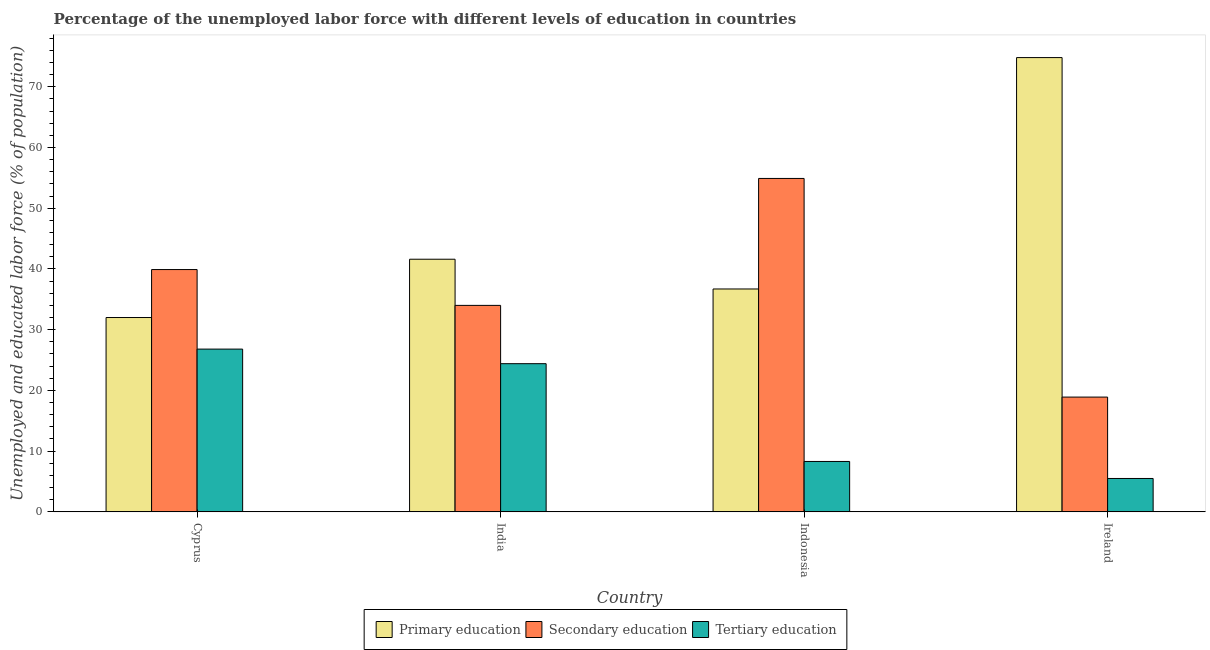How many groups of bars are there?
Your answer should be compact. 4. Are the number of bars per tick equal to the number of legend labels?
Your response must be concise. Yes. How many bars are there on the 3rd tick from the left?
Make the answer very short. 3. How many bars are there on the 1st tick from the right?
Provide a succinct answer. 3. What is the label of the 3rd group of bars from the left?
Provide a succinct answer. Indonesia. In how many cases, is the number of bars for a given country not equal to the number of legend labels?
Keep it short and to the point. 0. What is the percentage of labor force who received primary education in Indonesia?
Your response must be concise. 36.7. Across all countries, what is the maximum percentage of labor force who received tertiary education?
Your response must be concise. 26.8. Across all countries, what is the minimum percentage of labor force who received secondary education?
Provide a succinct answer. 18.9. In which country was the percentage of labor force who received primary education maximum?
Give a very brief answer. Ireland. In which country was the percentage of labor force who received primary education minimum?
Offer a very short reply. Cyprus. What is the total percentage of labor force who received primary education in the graph?
Keep it short and to the point. 185.1. What is the difference between the percentage of labor force who received secondary education in Cyprus and that in India?
Keep it short and to the point. 5.9. What is the difference between the percentage of labor force who received primary education in Cyprus and the percentage of labor force who received secondary education in Ireland?
Give a very brief answer. 13.1. What is the average percentage of labor force who received tertiary education per country?
Provide a short and direct response. 16.25. What is the difference between the percentage of labor force who received tertiary education and percentage of labor force who received secondary education in Indonesia?
Make the answer very short. -46.6. What is the ratio of the percentage of labor force who received secondary education in India to that in Ireland?
Make the answer very short. 1.8. What is the difference between the highest and the second highest percentage of labor force who received tertiary education?
Provide a short and direct response. 2.4. What is the difference between the highest and the lowest percentage of labor force who received primary education?
Ensure brevity in your answer.  42.8. Is the sum of the percentage of labor force who received tertiary education in India and Ireland greater than the maximum percentage of labor force who received secondary education across all countries?
Your response must be concise. No. What does the 2nd bar from the left in India represents?
Your answer should be compact. Secondary education. What does the 1st bar from the right in Ireland represents?
Your answer should be very brief. Tertiary education. Is it the case that in every country, the sum of the percentage of labor force who received primary education and percentage of labor force who received secondary education is greater than the percentage of labor force who received tertiary education?
Your answer should be very brief. Yes. Are all the bars in the graph horizontal?
Provide a short and direct response. No. How many countries are there in the graph?
Provide a short and direct response. 4. Does the graph contain any zero values?
Make the answer very short. No. Where does the legend appear in the graph?
Offer a terse response. Bottom center. How many legend labels are there?
Ensure brevity in your answer.  3. What is the title of the graph?
Keep it short and to the point. Percentage of the unemployed labor force with different levels of education in countries. Does "Self-employed" appear as one of the legend labels in the graph?
Offer a terse response. No. What is the label or title of the Y-axis?
Provide a short and direct response. Unemployed and educated labor force (% of population). What is the Unemployed and educated labor force (% of population) of Secondary education in Cyprus?
Keep it short and to the point. 39.9. What is the Unemployed and educated labor force (% of population) of Tertiary education in Cyprus?
Offer a terse response. 26.8. What is the Unemployed and educated labor force (% of population) of Primary education in India?
Offer a terse response. 41.6. What is the Unemployed and educated labor force (% of population) in Tertiary education in India?
Give a very brief answer. 24.4. What is the Unemployed and educated labor force (% of population) in Primary education in Indonesia?
Provide a succinct answer. 36.7. What is the Unemployed and educated labor force (% of population) of Secondary education in Indonesia?
Provide a short and direct response. 54.9. What is the Unemployed and educated labor force (% of population) in Tertiary education in Indonesia?
Your response must be concise. 8.3. What is the Unemployed and educated labor force (% of population) of Primary education in Ireland?
Provide a succinct answer. 74.8. What is the Unemployed and educated labor force (% of population) in Secondary education in Ireland?
Provide a short and direct response. 18.9. Across all countries, what is the maximum Unemployed and educated labor force (% of population) of Primary education?
Provide a succinct answer. 74.8. Across all countries, what is the maximum Unemployed and educated labor force (% of population) in Secondary education?
Your answer should be compact. 54.9. Across all countries, what is the maximum Unemployed and educated labor force (% of population) in Tertiary education?
Your answer should be very brief. 26.8. Across all countries, what is the minimum Unemployed and educated labor force (% of population) in Secondary education?
Your answer should be very brief. 18.9. Across all countries, what is the minimum Unemployed and educated labor force (% of population) in Tertiary education?
Offer a terse response. 5.5. What is the total Unemployed and educated labor force (% of population) in Primary education in the graph?
Your answer should be very brief. 185.1. What is the total Unemployed and educated labor force (% of population) in Secondary education in the graph?
Offer a terse response. 147.7. What is the total Unemployed and educated labor force (% of population) in Tertiary education in the graph?
Your answer should be compact. 65. What is the difference between the Unemployed and educated labor force (% of population) in Secondary education in Cyprus and that in India?
Your response must be concise. 5.9. What is the difference between the Unemployed and educated labor force (% of population) of Primary education in Cyprus and that in Ireland?
Ensure brevity in your answer.  -42.8. What is the difference between the Unemployed and educated labor force (% of population) in Secondary education in Cyprus and that in Ireland?
Keep it short and to the point. 21. What is the difference between the Unemployed and educated labor force (% of population) in Tertiary education in Cyprus and that in Ireland?
Offer a very short reply. 21.3. What is the difference between the Unemployed and educated labor force (% of population) of Primary education in India and that in Indonesia?
Make the answer very short. 4.9. What is the difference between the Unemployed and educated labor force (% of population) of Secondary education in India and that in Indonesia?
Give a very brief answer. -20.9. What is the difference between the Unemployed and educated labor force (% of population) in Tertiary education in India and that in Indonesia?
Your response must be concise. 16.1. What is the difference between the Unemployed and educated labor force (% of population) of Primary education in India and that in Ireland?
Provide a succinct answer. -33.2. What is the difference between the Unemployed and educated labor force (% of population) in Tertiary education in India and that in Ireland?
Give a very brief answer. 18.9. What is the difference between the Unemployed and educated labor force (% of population) of Primary education in Indonesia and that in Ireland?
Your answer should be very brief. -38.1. What is the difference between the Unemployed and educated labor force (% of population) of Secondary education in Indonesia and that in Ireland?
Your answer should be very brief. 36. What is the difference between the Unemployed and educated labor force (% of population) of Tertiary education in Indonesia and that in Ireland?
Make the answer very short. 2.8. What is the difference between the Unemployed and educated labor force (% of population) in Secondary education in Cyprus and the Unemployed and educated labor force (% of population) in Tertiary education in India?
Your answer should be compact. 15.5. What is the difference between the Unemployed and educated labor force (% of population) of Primary education in Cyprus and the Unemployed and educated labor force (% of population) of Secondary education in Indonesia?
Your answer should be very brief. -22.9. What is the difference between the Unemployed and educated labor force (% of population) of Primary education in Cyprus and the Unemployed and educated labor force (% of population) of Tertiary education in Indonesia?
Make the answer very short. 23.7. What is the difference between the Unemployed and educated labor force (% of population) of Secondary education in Cyprus and the Unemployed and educated labor force (% of population) of Tertiary education in Indonesia?
Provide a short and direct response. 31.6. What is the difference between the Unemployed and educated labor force (% of population) in Primary education in Cyprus and the Unemployed and educated labor force (% of population) in Secondary education in Ireland?
Your response must be concise. 13.1. What is the difference between the Unemployed and educated labor force (% of population) in Secondary education in Cyprus and the Unemployed and educated labor force (% of population) in Tertiary education in Ireland?
Provide a short and direct response. 34.4. What is the difference between the Unemployed and educated labor force (% of population) of Primary education in India and the Unemployed and educated labor force (% of population) of Tertiary education in Indonesia?
Provide a short and direct response. 33.3. What is the difference between the Unemployed and educated labor force (% of population) in Secondary education in India and the Unemployed and educated labor force (% of population) in Tertiary education in Indonesia?
Give a very brief answer. 25.7. What is the difference between the Unemployed and educated labor force (% of population) of Primary education in India and the Unemployed and educated labor force (% of population) of Secondary education in Ireland?
Your response must be concise. 22.7. What is the difference between the Unemployed and educated labor force (% of population) in Primary education in India and the Unemployed and educated labor force (% of population) in Tertiary education in Ireland?
Your response must be concise. 36.1. What is the difference between the Unemployed and educated labor force (% of population) in Primary education in Indonesia and the Unemployed and educated labor force (% of population) in Tertiary education in Ireland?
Provide a short and direct response. 31.2. What is the difference between the Unemployed and educated labor force (% of population) in Secondary education in Indonesia and the Unemployed and educated labor force (% of population) in Tertiary education in Ireland?
Your response must be concise. 49.4. What is the average Unemployed and educated labor force (% of population) of Primary education per country?
Offer a very short reply. 46.27. What is the average Unemployed and educated labor force (% of population) of Secondary education per country?
Provide a succinct answer. 36.92. What is the average Unemployed and educated labor force (% of population) in Tertiary education per country?
Offer a terse response. 16.25. What is the difference between the Unemployed and educated labor force (% of population) in Primary education and Unemployed and educated labor force (% of population) in Secondary education in Cyprus?
Provide a short and direct response. -7.9. What is the difference between the Unemployed and educated labor force (% of population) of Secondary education and Unemployed and educated labor force (% of population) of Tertiary education in Cyprus?
Provide a succinct answer. 13.1. What is the difference between the Unemployed and educated labor force (% of population) of Primary education and Unemployed and educated labor force (% of population) of Secondary education in India?
Keep it short and to the point. 7.6. What is the difference between the Unemployed and educated labor force (% of population) in Secondary education and Unemployed and educated labor force (% of population) in Tertiary education in India?
Provide a succinct answer. 9.6. What is the difference between the Unemployed and educated labor force (% of population) of Primary education and Unemployed and educated labor force (% of population) of Secondary education in Indonesia?
Your response must be concise. -18.2. What is the difference between the Unemployed and educated labor force (% of population) of Primary education and Unemployed and educated labor force (% of population) of Tertiary education in Indonesia?
Keep it short and to the point. 28.4. What is the difference between the Unemployed and educated labor force (% of population) of Secondary education and Unemployed and educated labor force (% of population) of Tertiary education in Indonesia?
Ensure brevity in your answer.  46.6. What is the difference between the Unemployed and educated labor force (% of population) of Primary education and Unemployed and educated labor force (% of population) of Secondary education in Ireland?
Your answer should be very brief. 55.9. What is the difference between the Unemployed and educated labor force (% of population) in Primary education and Unemployed and educated labor force (% of population) in Tertiary education in Ireland?
Give a very brief answer. 69.3. What is the ratio of the Unemployed and educated labor force (% of population) of Primary education in Cyprus to that in India?
Offer a terse response. 0.77. What is the ratio of the Unemployed and educated labor force (% of population) of Secondary education in Cyprus to that in India?
Your answer should be compact. 1.17. What is the ratio of the Unemployed and educated labor force (% of population) of Tertiary education in Cyprus to that in India?
Offer a very short reply. 1.1. What is the ratio of the Unemployed and educated labor force (% of population) of Primary education in Cyprus to that in Indonesia?
Offer a terse response. 0.87. What is the ratio of the Unemployed and educated labor force (% of population) in Secondary education in Cyprus to that in Indonesia?
Provide a short and direct response. 0.73. What is the ratio of the Unemployed and educated labor force (% of population) of Tertiary education in Cyprus to that in Indonesia?
Make the answer very short. 3.23. What is the ratio of the Unemployed and educated labor force (% of population) of Primary education in Cyprus to that in Ireland?
Ensure brevity in your answer.  0.43. What is the ratio of the Unemployed and educated labor force (% of population) of Secondary education in Cyprus to that in Ireland?
Provide a short and direct response. 2.11. What is the ratio of the Unemployed and educated labor force (% of population) of Tertiary education in Cyprus to that in Ireland?
Keep it short and to the point. 4.87. What is the ratio of the Unemployed and educated labor force (% of population) in Primary education in India to that in Indonesia?
Provide a short and direct response. 1.13. What is the ratio of the Unemployed and educated labor force (% of population) in Secondary education in India to that in Indonesia?
Your answer should be very brief. 0.62. What is the ratio of the Unemployed and educated labor force (% of population) of Tertiary education in India to that in Indonesia?
Ensure brevity in your answer.  2.94. What is the ratio of the Unemployed and educated labor force (% of population) of Primary education in India to that in Ireland?
Keep it short and to the point. 0.56. What is the ratio of the Unemployed and educated labor force (% of population) in Secondary education in India to that in Ireland?
Your answer should be very brief. 1.8. What is the ratio of the Unemployed and educated labor force (% of population) of Tertiary education in India to that in Ireland?
Provide a succinct answer. 4.44. What is the ratio of the Unemployed and educated labor force (% of population) in Primary education in Indonesia to that in Ireland?
Offer a terse response. 0.49. What is the ratio of the Unemployed and educated labor force (% of population) in Secondary education in Indonesia to that in Ireland?
Your answer should be very brief. 2.9. What is the ratio of the Unemployed and educated labor force (% of population) in Tertiary education in Indonesia to that in Ireland?
Provide a succinct answer. 1.51. What is the difference between the highest and the second highest Unemployed and educated labor force (% of population) in Primary education?
Provide a short and direct response. 33.2. What is the difference between the highest and the second highest Unemployed and educated labor force (% of population) of Secondary education?
Your answer should be compact. 15. What is the difference between the highest and the second highest Unemployed and educated labor force (% of population) in Tertiary education?
Offer a very short reply. 2.4. What is the difference between the highest and the lowest Unemployed and educated labor force (% of population) of Primary education?
Your answer should be very brief. 42.8. What is the difference between the highest and the lowest Unemployed and educated labor force (% of population) of Tertiary education?
Offer a very short reply. 21.3. 